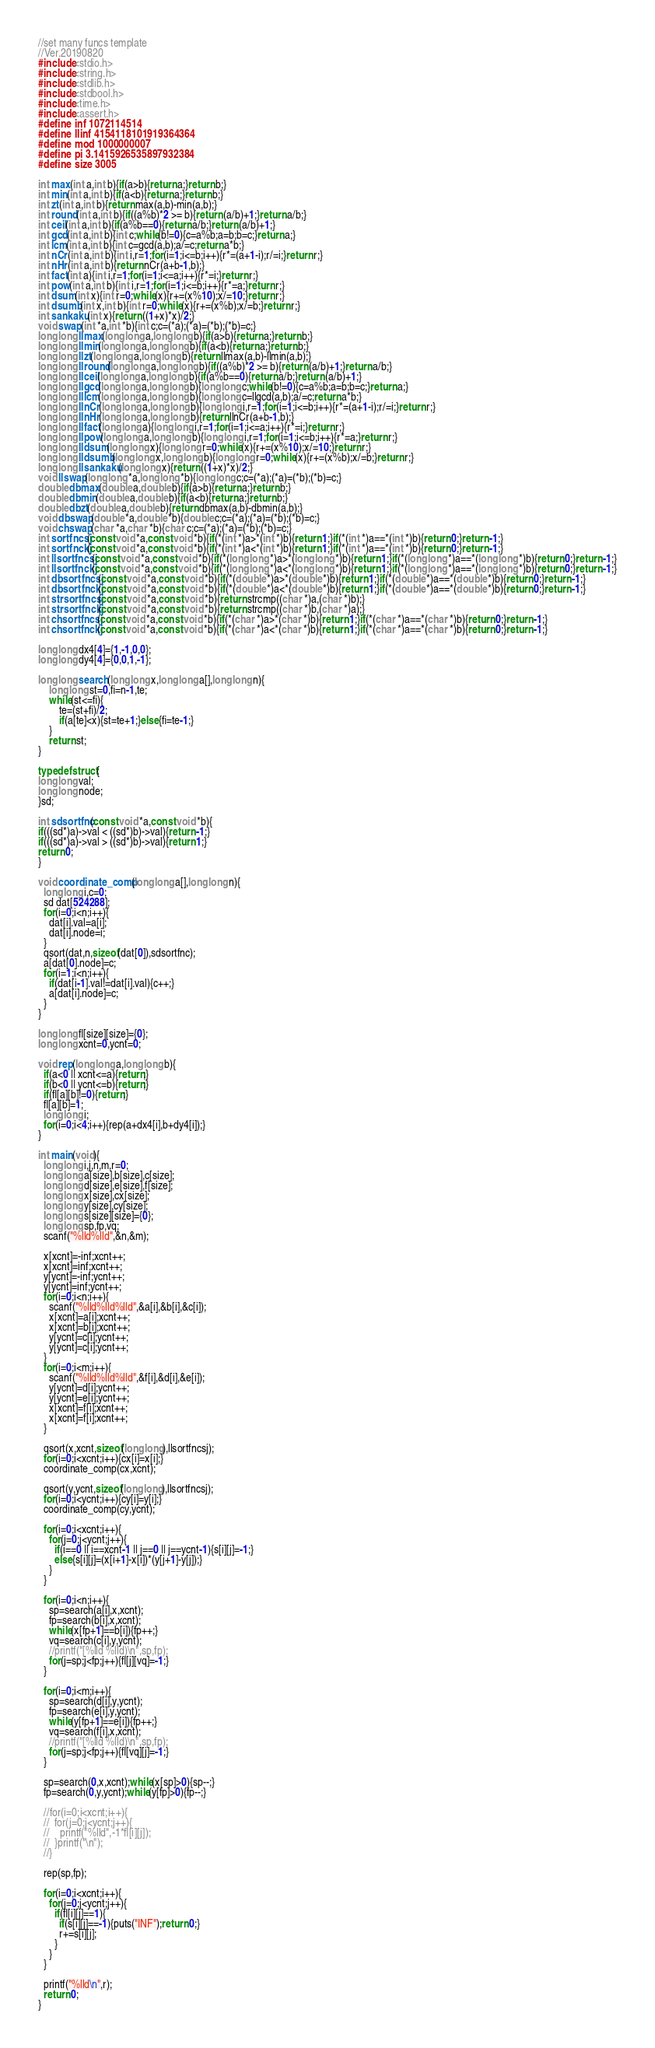<code> <loc_0><loc_0><loc_500><loc_500><_C_>//set many funcs template
//Ver.20190820
#include<stdio.h>
#include<string.h>
#include<stdlib.h>
#include<stdbool.h>
#include<time.h>
#include<assert.h>
#define inf 1072114514
#define llinf 4154118101919364364
#define mod 1000000007
#define pi 3.1415926535897932384
#define size 3005

int max(int a,int b){if(a>b){return a;}return b;}
int min(int a,int b){if(a<b){return a;}return b;}
int zt(int a,int b){return max(a,b)-min(a,b);}
int round(int a,int b){if((a%b)*2 >= b){return (a/b)+1;}return a/b;}
int ceil(int a,int b){if(a%b==0){return a/b;}return (a/b)+1;}
int gcd(int a,int b){int c;while(b!=0){c=a%b;a=b;b=c;}return a;}
int lcm(int a,int b){int c=gcd(a,b);a/=c;return a*b;}
int nCr(int a,int b){int i,r=1;for(i=1;i<=b;i++){r*=(a+1-i);r/=i;}return r;}
int nHr(int a,int b){return nCr(a+b-1,b);}
int fact(int a){int i,r=1;for(i=1;i<=a;i++){r*=i;}return r;}
int pow(int a,int b){int i,r=1;for(i=1;i<=b;i++){r*=a;}return r;}
int dsum(int x){int r=0;while(x){r+=(x%10);x/=10;}return r;}
int dsumb(int x,int b){int r=0;while(x){r+=(x%b);x/=b;}return r;}
int sankaku(int x){return ((1+x)*x)/2;}
void swap(int *a,int *b){int c;c=(*a);(*a)=(*b);(*b)=c;}
long long llmax(long long a,long long b){if(a>b){return a;}return b;}
long long llmin(long long a,long long b){if(a<b){return a;}return b;}
long long llzt(long long a,long long b){return llmax(a,b)-llmin(a,b);}
long long llround(long long a,long long b){if((a%b)*2 >= b){return (a/b)+1;}return a/b;}
long long llceil(long long a,long long b){if(a%b==0){return a/b;}return (a/b)+1;}
long long llgcd(long long a,long long b){long long c;while(b!=0){c=a%b;a=b;b=c;}return a;}
long long lllcm(long long a,long long b){long long c=llgcd(a,b);a/=c;return a*b;}
long long llnCr(long long a,long long b){long long i,r=1;for(i=1;i<=b;i++){r*=(a+1-i);r/=i;}return r;}
long long llnHr(long long a,long long b){return llnCr(a+b-1,b);}
long long llfact(long long a){long long i,r=1;for(i=1;i<=a;i++){r*=i;}return r;}
long long llpow(long long a,long long b){long long i,r=1;for(i=1;i<=b;i++){r*=a;}return r;}
long long lldsum(long long x){long long r=0;while(x){r+=(x%10);x/=10;}return r;}
long long lldsumb(long long x,long long b){long long r=0;while(x){r+=(x%b);x/=b;}return r;}
long long llsankaku(long long x){return ((1+x)*x)/2;}
void llswap(long long *a,long long *b){long long c;c=(*a);(*a)=(*b);(*b)=c;}
double dbmax(double a,double b){if(a>b){return a;}return b;}
double dbmin(double a,double b){if(a<b){return a;}return b;}
double dbzt(double a,double b){return dbmax(a,b)-dbmin(a,b);}
void dbswap(double *a,double *b){double c;c=(*a);(*a)=(*b);(*b)=c;}
void chswap(char *a,char *b){char c;c=(*a);(*a)=(*b);(*b)=c;}
int sortfncsj(const void *a,const void *b){if(*(int *)a>*(int *)b){return 1;}if(*(int *)a==*(int *)b){return 0;}return -1;}
int sortfnckj(const void *a,const void *b){if(*(int *)a<*(int *)b){return 1;}if(*(int *)a==*(int *)b){return 0;}return -1;}
int llsortfncsj(const void *a,const void *b){if(*(long long *)a>*(long long *)b){return 1;}if(*(long long *)a==*(long long *)b){return 0;}return -1;}
int llsortfnckj(const void *a,const void *b){if(*(long long *)a<*(long long *)b){return 1;}if(*(long long *)a==*(long long *)b){return 0;}return -1;}
int dbsortfncsj(const void *a,const void *b){if(*(double *)a>*(double *)b){return 1;}if(*(double *)a==*(double *)b){return 0;}return -1;}
int dbsortfnckj(const void *a,const void *b){if(*(double *)a<*(double *)b){return 1;}if(*(double *)a==*(double *)b){return 0;}return -1;}
int strsortfncsj(const void *a,const void *b){return strcmp((char *)a,(char *)b);}
int strsortfnckj(const void *a,const void *b){return strcmp((char *)b,(char *)a);}
int chsortfncsj(const void *a,const void *b){if(*(char *)a>*(char *)b){return 1;}if(*(char *)a==*(char *)b){return 0;}return -1;}
int chsortfnckj(const void *a,const void *b){if(*(char *)a<*(char *)b){return 1;}if(*(char *)a==*(char *)b){return 0;}return -1;}

long long dx4[4]={1,-1,0,0};
long long dy4[4]={0,0,1,-1};

long long search(long long x,long long a[],long long n){
    long long st=0,fi=n-1,te;
    while(st<=fi){
        te=(st+fi)/2;
        if(a[te]<x){st=te+1;}else{fi=te-1;}
    }
    return st;
}

typedef struct{
long long val;
long long node;
}sd;

int sdsortfnc(const void *a,const void *b){
if(((sd*)a)->val < ((sd*)b)->val){return -1;}
if(((sd*)a)->val > ((sd*)b)->val){return 1;}
return 0;
}

void coordinate_comp(long long a[],long long n){
  long long i,c=0;
  sd dat[524288];
  for(i=0;i<n;i++){
    dat[i].val=a[i];
    dat[i].node=i;
  }
  qsort(dat,n,sizeof(dat[0]),sdsortfnc);
  a[dat[0].node]=c;
  for(i=1;i<n;i++){
    if(dat[i-1].val!=dat[i].val){c++;}
    a[dat[i].node]=c;
  }
}

long long fl[size][size]={0};
long long xcnt=0,ycnt=0;

void rep(long long a,long long b){
  if(a<0 || xcnt<=a){return;}
  if(b<0 || ycnt<=b){return;}
  if(fl[a][b]!=0){return;}
  fl[a][b]=1;
  long long i;
  for(i=0;i<4;i++){rep(a+dx4[i],b+dy4[i]);}
}

int main(void){
  long long i,j,n,m,r=0;
  long long a[size],b[size],c[size];
  long long d[size],e[size],f[size];
  long long x[size],cx[size];
  long long y[size],cy[size];
  long long s[size][size]={0};
  long long sp,fp,vq;
  scanf("%lld%lld",&n,&m);
  
  x[xcnt]=-inf;xcnt++;
  x[xcnt]=inf;xcnt++;
  y[ycnt]=-inf;ycnt++;
  y[ycnt]=inf;ycnt++;
  for(i=0;i<n;i++){
    scanf("%lld%lld%lld",&a[i],&b[i],&c[i]);
    x[xcnt]=a[i];xcnt++;
    x[xcnt]=b[i];xcnt++;
    y[ycnt]=c[i];ycnt++;
    y[ycnt]=c[i];ycnt++;
  }
  for(i=0;i<m;i++){
    scanf("%lld%lld%lld",&f[i],&d[i],&e[i]);
    y[ycnt]=d[i];ycnt++;
    y[ycnt]=e[i];ycnt++;
    x[xcnt]=f[i];xcnt++;
    x[xcnt]=f[i];xcnt++;
  }

  qsort(x,xcnt,sizeof(long long),llsortfncsj);
  for(i=0;i<xcnt;i++){cx[i]=x[i];}
  coordinate_comp(cx,xcnt);
  
  qsort(y,ycnt,sizeof(long long),llsortfncsj);
  for(i=0;i<ycnt;i++){cy[i]=y[i];}
  coordinate_comp(cy,ycnt); 

  for(i=0;i<xcnt;i++){
    for(j=0;j<ycnt;j++){
      if(i==0 || i==xcnt-1 || j==0 || j==ycnt-1){s[i][j]=-1;}
      else{s[i][j]=(x[i+1]-x[i])*(y[j+1]-y[j]);}
    }
  }

  for(i=0;i<n;i++){
    sp=search(a[i],x,xcnt);
    fp=search(b[i],x,xcnt);
    while(x[fp+1]==b[i]){fp++;}
    vq=search(c[i],y,ycnt);
    //printf("[%lld %lld)\n",sp,fp);
    for(j=sp;j<fp;j++){fl[j][vq]=-1;}
  }
  
  for(i=0;i<m;i++){
    sp=search(d[i],y,ycnt);
    fp=search(e[i],y,ycnt);
    while(y[fp+1]==e[i]){fp++;}
    vq=search(f[i],x,xcnt);
    //printf("[%lld %lld)\n",sp,fp);
    for(j=sp;j<fp;j++){fl[vq][j]=-1;}
  }
  
  sp=search(0,x,xcnt);while(x[sp]>0){sp--;}
  fp=search(0,y,ycnt);while(y[fp]>0){fp--;}
  
  //for(i=0;i<xcnt;i++){
  //  for(j=0;j<ycnt;j++){
  //    printf("%lld",-1*fl[i][j]);
  //  }printf("\n");
  //}
  
  rep(sp,fp);

  for(i=0;i<xcnt;i++){
    for(j=0;j<ycnt;j++){
      if(fl[i][j]==1){
        if(s[i][j]==-1){puts("INF");return 0;}
        r+=s[i][j];
      }
    }
  }
  
  printf("%lld\n",r);
  return 0;
}
</code> 